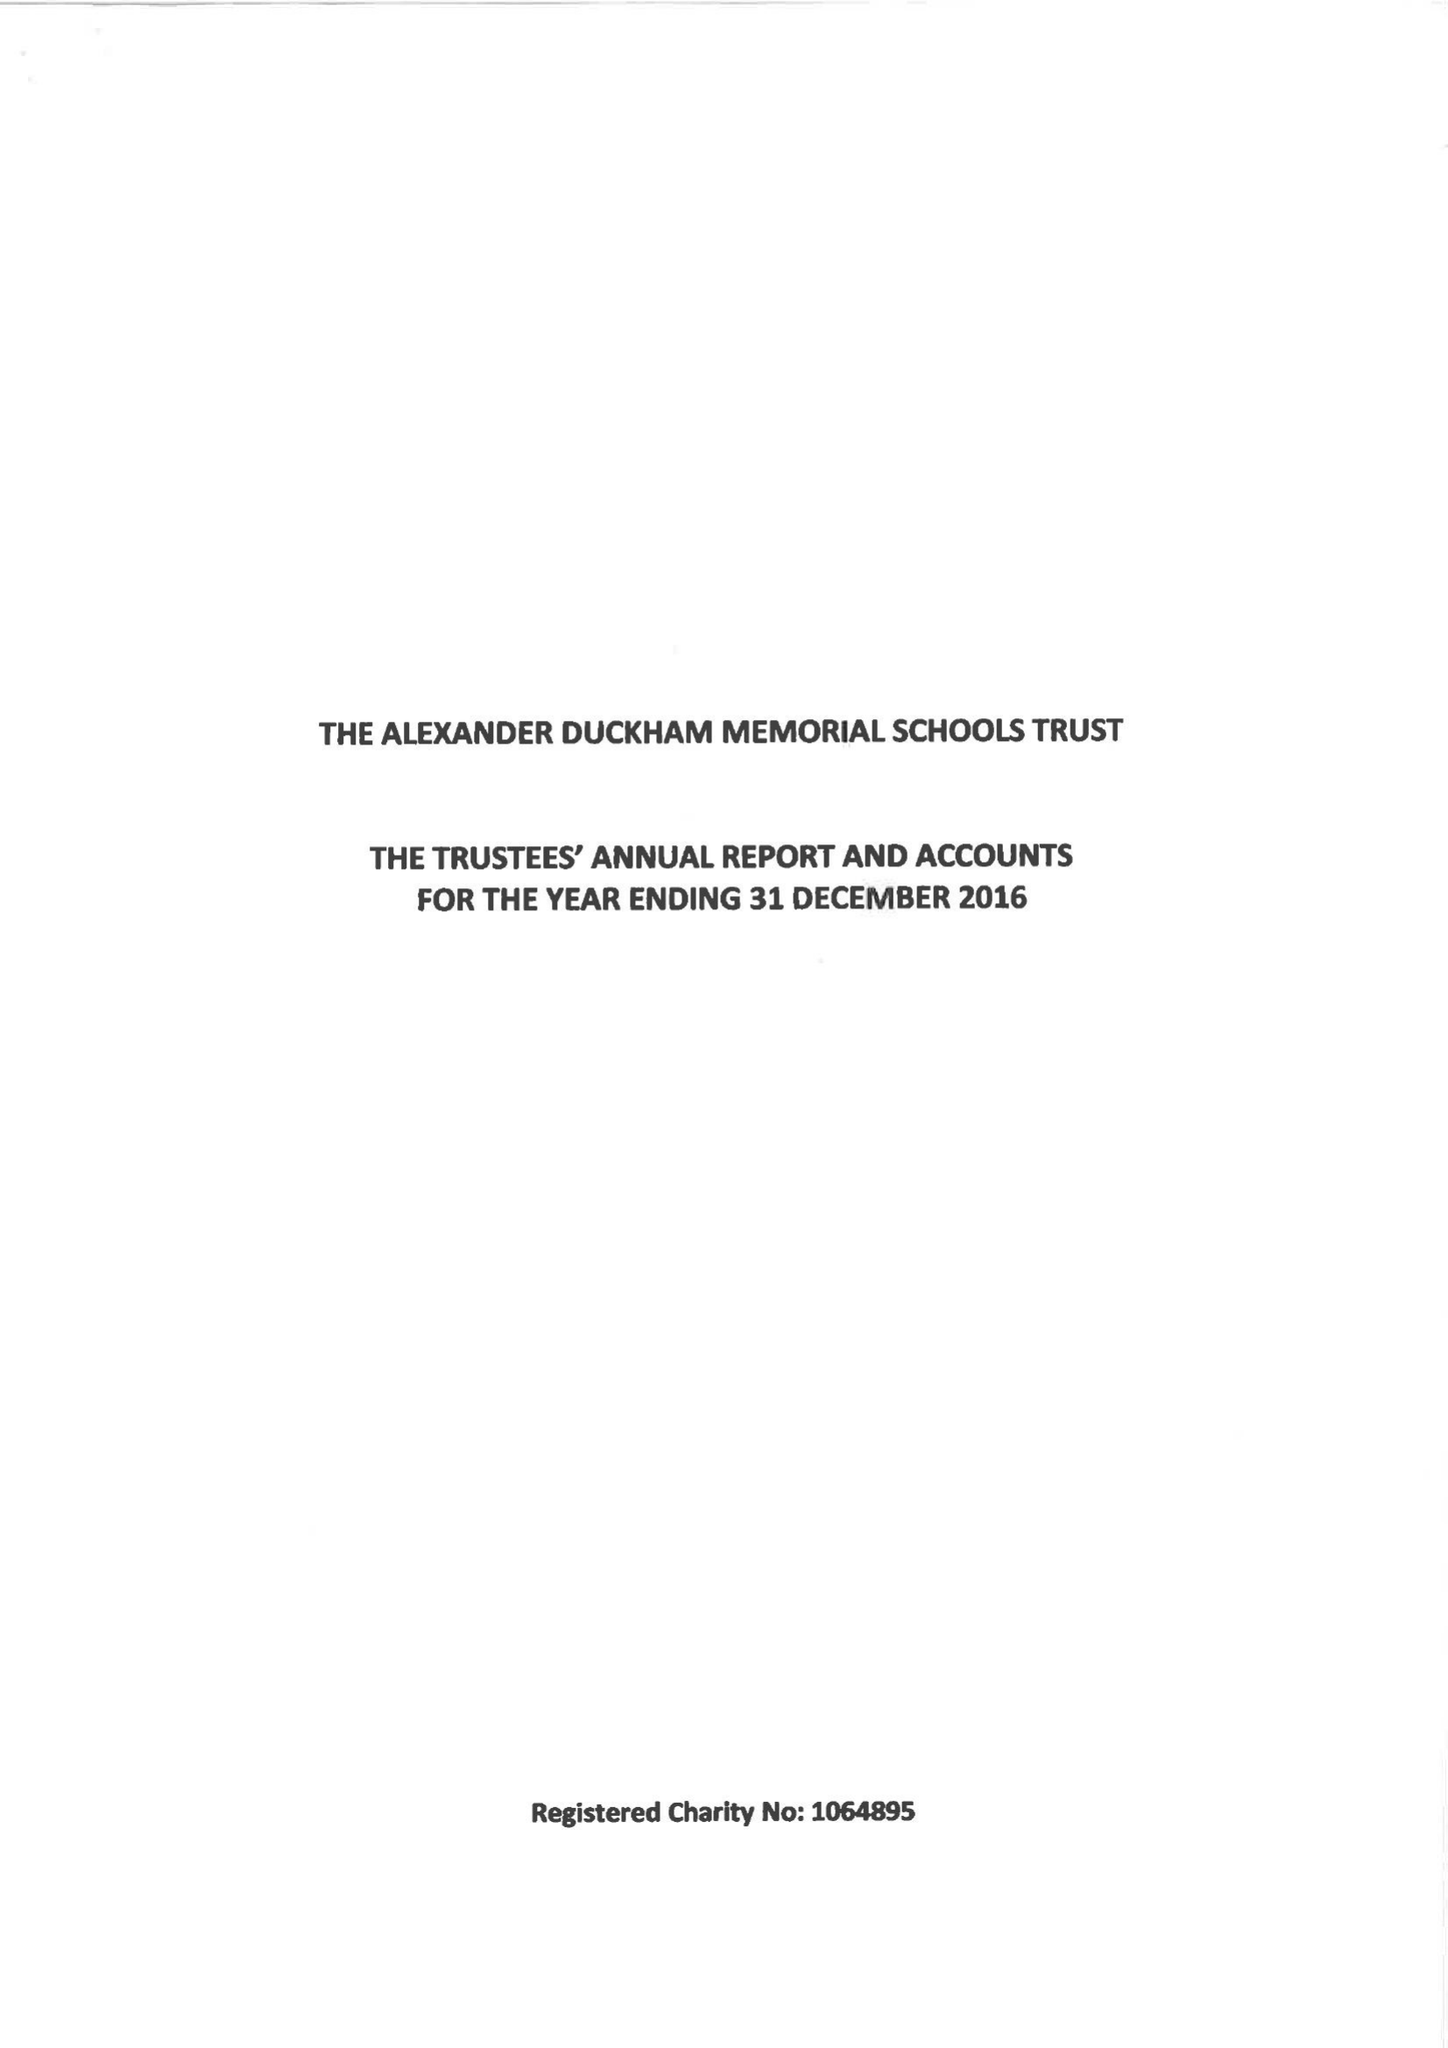What is the value for the income_annually_in_british_pounds?
Answer the question using a single word or phrase. 147321.00 